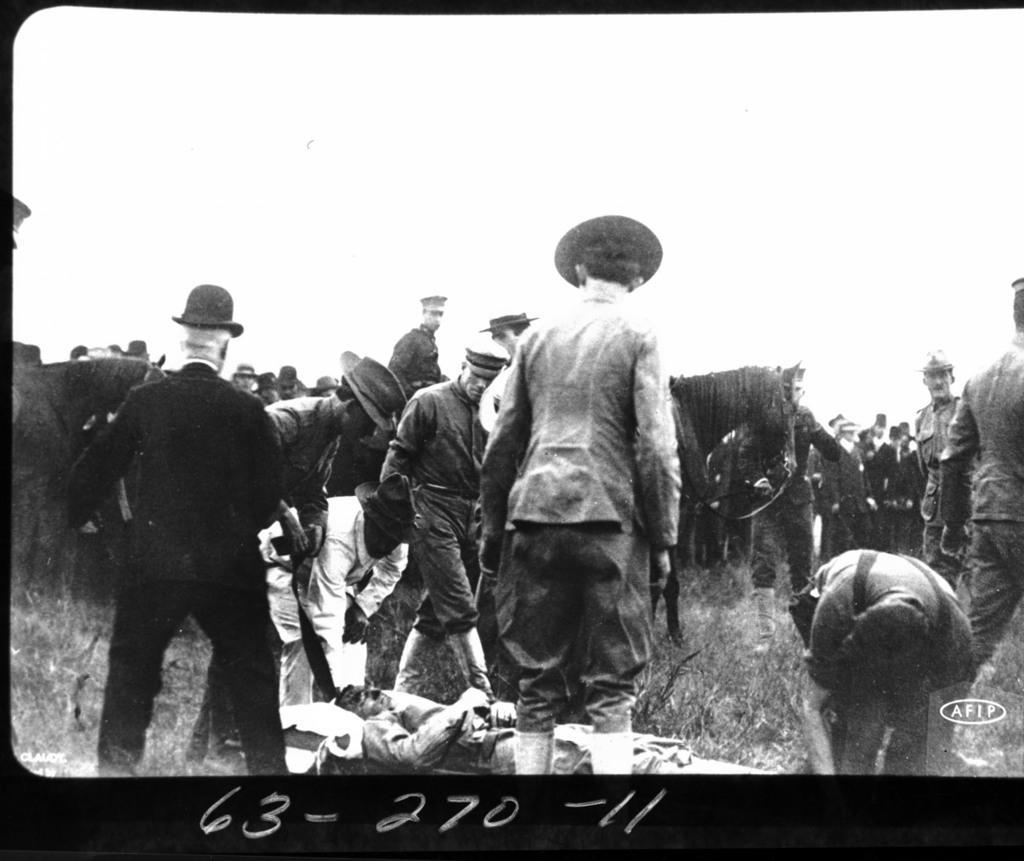How would you summarize this image in a sentence or two? In this image, we can see a poster with some images and text. 